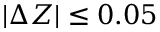Convert formula to latex. <formula><loc_0><loc_0><loc_500><loc_500>| \Delta Z | \leq 0 . 0 5</formula> 